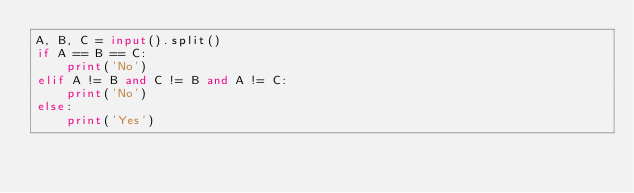Convert code to text. <code><loc_0><loc_0><loc_500><loc_500><_Python_>A, B, C = input().split()
if A == B == C:
    print('No')
elif A != B and C != B and A != C:
    print('No')     
else:
    print('Yes')    
</code> 